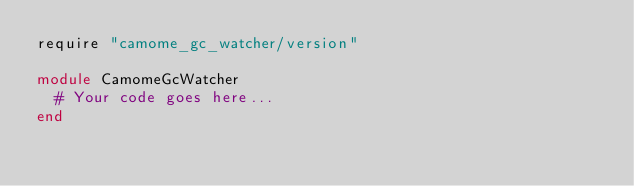Convert code to text. <code><loc_0><loc_0><loc_500><loc_500><_Ruby_>require "camome_gc_watcher/version"

module CamomeGcWatcher
  # Your code goes here...
end
</code> 